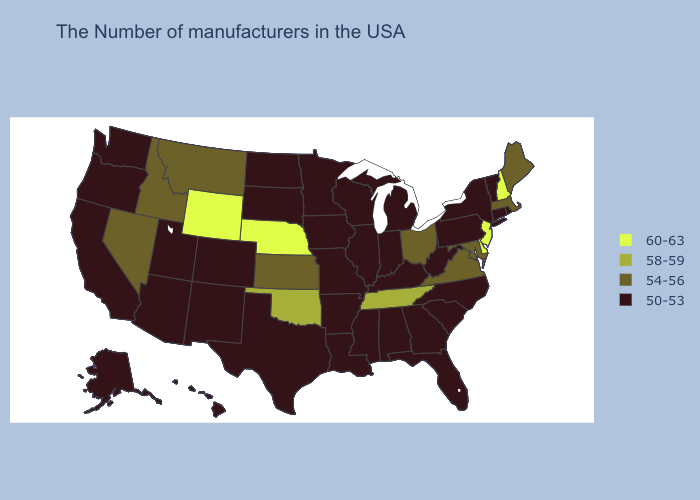What is the value of Utah?
Short answer required. 50-53. Name the states that have a value in the range 50-53?
Keep it brief. Rhode Island, Vermont, Connecticut, New York, Pennsylvania, North Carolina, South Carolina, West Virginia, Florida, Georgia, Michigan, Kentucky, Indiana, Alabama, Wisconsin, Illinois, Mississippi, Louisiana, Missouri, Arkansas, Minnesota, Iowa, Texas, South Dakota, North Dakota, Colorado, New Mexico, Utah, Arizona, California, Washington, Oregon, Alaska, Hawaii. Among the states that border Montana , does Idaho have the lowest value?
Answer briefly. No. Does California have the highest value in the West?
Quick response, please. No. What is the lowest value in states that border Colorado?
Quick response, please. 50-53. Does Iowa have the lowest value in the MidWest?
Quick response, please. Yes. Among the states that border Washington , does Idaho have the highest value?
Keep it brief. Yes. Which states have the highest value in the USA?
Concise answer only. New Hampshire, New Jersey, Delaware, Nebraska, Wyoming. What is the highest value in the USA?
Be succinct. 60-63. Among the states that border Massachusetts , does New Hampshire have the lowest value?
Give a very brief answer. No. What is the value of Pennsylvania?
Give a very brief answer. 50-53. Does Michigan have the lowest value in the MidWest?
Quick response, please. Yes. Name the states that have a value in the range 50-53?
Give a very brief answer. Rhode Island, Vermont, Connecticut, New York, Pennsylvania, North Carolina, South Carolina, West Virginia, Florida, Georgia, Michigan, Kentucky, Indiana, Alabama, Wisconsin, Illinois, Mississippi, Louisiana, Missouri, Arkansas, Minnesota, Iowa, Texas, South Dakota, North Dakota, Colorado, New Mexico, Utah, Arizona, California, Washington, Oregon, Alaska, Hawaii. Name the states that have a value in the range 54-56?
Write a very short answer. Maine, Massachusetts, Maryland, Virginia, Ohio, Kansas, Montana, Idaho, Nevada. Does Utah have the highest value in the West?
Concise answer only. No. 